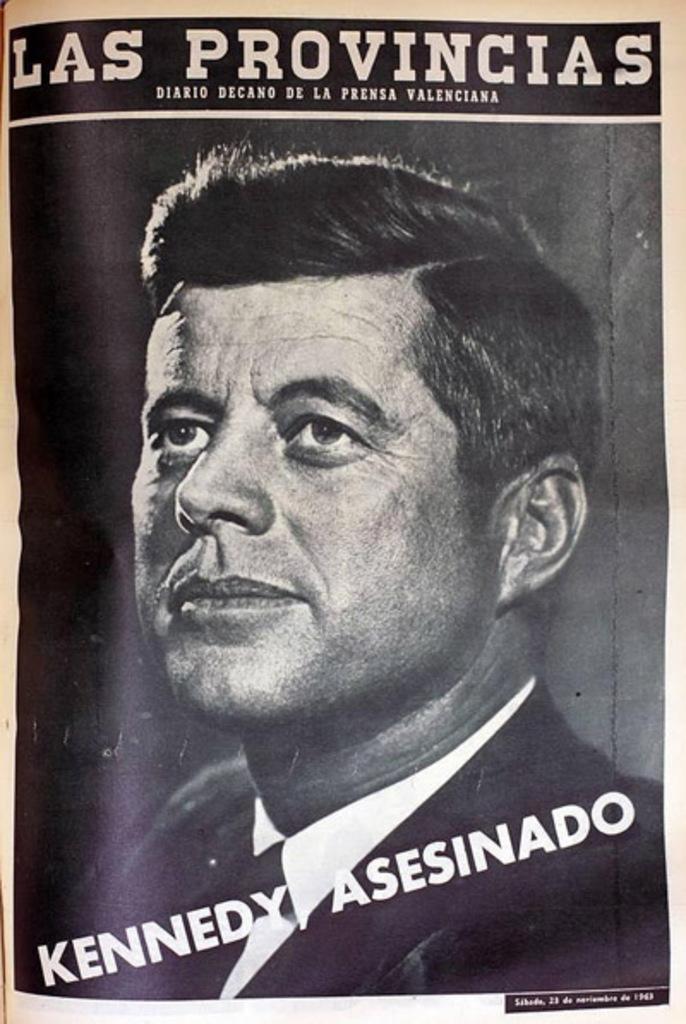What u.s. president is shown?
Your answer should be very brief. Kennedy. 